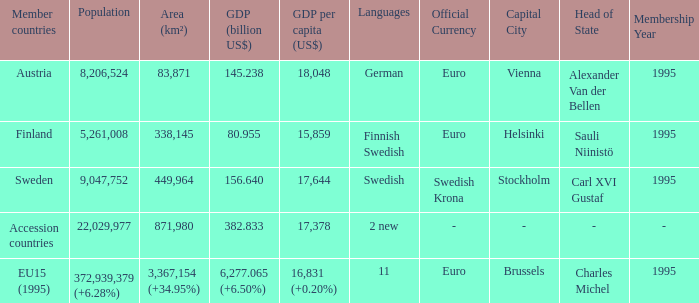Name the population for 11 languages 372,939,379 (+6.28%). Would you be able to parse every entry in this table? {'header': ['Member countries', 'Population', 'Area (km²)', 'GDP (billion US$)', 'GDP per capita (US$)', 'Languages', 'Official Currency', 'Capital City', 'Head of State', 'Membership Year'], 'rows': [['Austria', '8,206,524', '83,871', '145.238', '18,048', 'German', 'Euro', 'Vienna', 'Alexander Van der Bellen', '1995'], ['Finland', '5,261,008', '338,145', '80.955', '15,859', 'Finnish Swedish', 'Euro', 'Helsinki', 'Sauli Niinistö', '1995'], ['Sweden', '9,047,752', '449,964', '156.640', '17,644', 'Swedish', 'Swedish Krona', 'Stockholm', 'Carl XVI Gustaf', '1995'], ['Accession countries', '22,029,977', '871,980', '382.833', '17,378', '2 new', '-', '-', '-', '-'], ['EU15 (1995)', '372,939,379 (+6.28%)', '3,367,154 (+34.95%)', '6,277.065 (+6.50%)', '16,831 (+0.20%)', '11', 'Euro', 'Brussels', 'Charles Michel', '1995']]} 